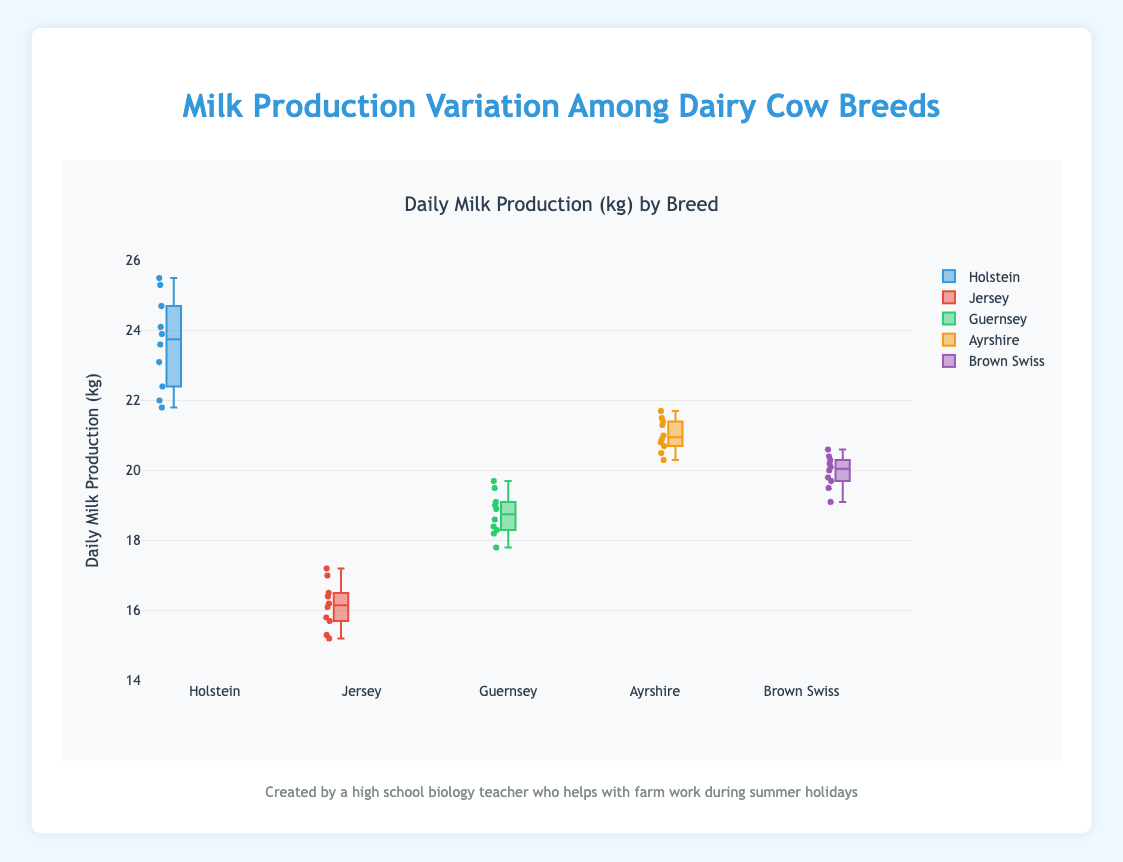What is the title of the plot? The title of the plot is provided at the top, clearly stating the subject of the visualization.
Answer: Daily Milk Production (kg) by Breed What is the median milk production for Holstein cows? The median is the middle value in a sorted list of numbers. For Holstein, the values in ascending order are [21.8, 22.0, 22.4, 23.1, 23.6, 23.9, 24.1, 24.7, 25.3, 25.5]; the median is (23.6 + 23.9)/2.
Answer: 23.75 kg Which breed has the smallest range in milk production? The range is the difference between the maximum and minimum values in each dataset. By observing the lengths of the boxes (interquartile ranges) and the whiskers (spread), we determine which breed has the smallest range. Ayrshire shows the smallest horizontal box and shortest whiskers.
Answer: Ayrshire What's the general trend in daily milk production across different cow breeds? By observing the medians and the lengths of the boxes and whiskers, we see that Holstein cows generally produce the most milk, followed by Ayrshire, Brown Swiss, Guernsey, and finally Jersey, which produce the least.
Answer: Holstein > Ayrshire > Brown Swiss > Guernsey > Jersey How many breeds of dairy cows are compared in the plot? The number of breeds is indicated by the distinct boxes or groups along the x-axis. Each breed has its own data series.
Answer: 5 breeds Which breed has the highest maximum daily milk production? This is identified by the highest point on the plot, which is the top segment of the whisker for each breed. Holstein's top whisker reaches the highest value.
Answer: Holstein Compare the interquartile range (IQR) of Jersey and Guernsey cows. The IQR is the range of the middle 50% of the data for each box, visible as the length of the box itself. We measure the difference between the first quartile (Q1) and the third quartile (Q3). Jersey: (16.2 - 15.5) = 0.7, Guernsey: (19.1 - 18.2) = 0.9
Answer: Jersey: 0.7, Guernsey: 0.9 Which breed has the highest median milk production and what is that value? The median is shown as the line inside each box. The Holstein breed has the highest median, represented by the highest horizontal line within its box. The value can be read directly from the median line’s position on the y-axis.
Answer: Holstein, 23.75 kg 